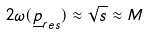<formula> <loc_0><loc_0><loc_500><loc_500>2 \omega ( { \underline { p } } _ { r e s } ) \approx \sqrt { s } \approx M</formula> 